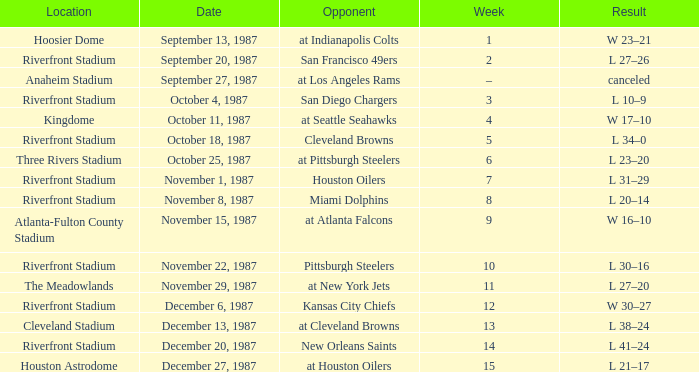What was the result of the game at the Riverfront Stadium after week 8? L 20–14. 